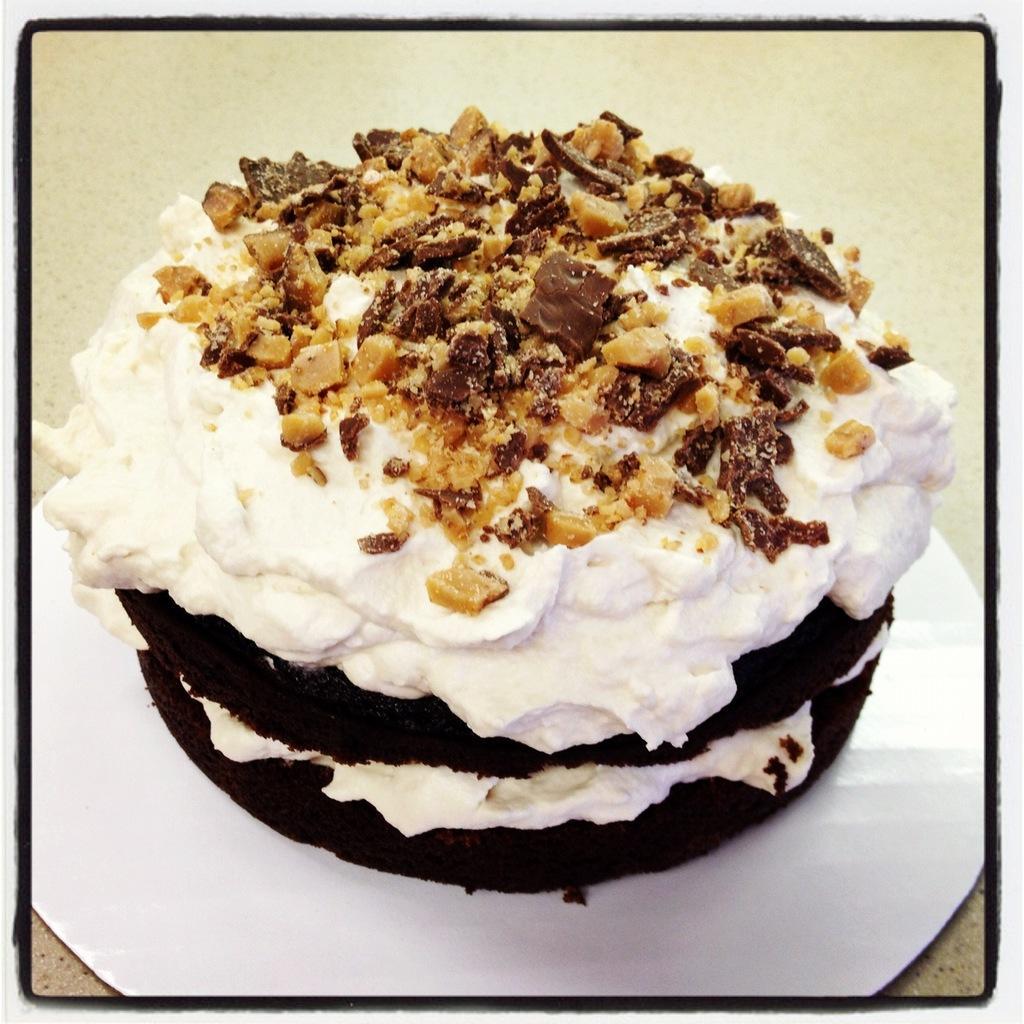Could you give a brief overview of what you see in this image? In this image I can see the surface which is cream in color and on the surface I can see a white colored plate and on the plate I can see a cake which is black, white and brown in color. 